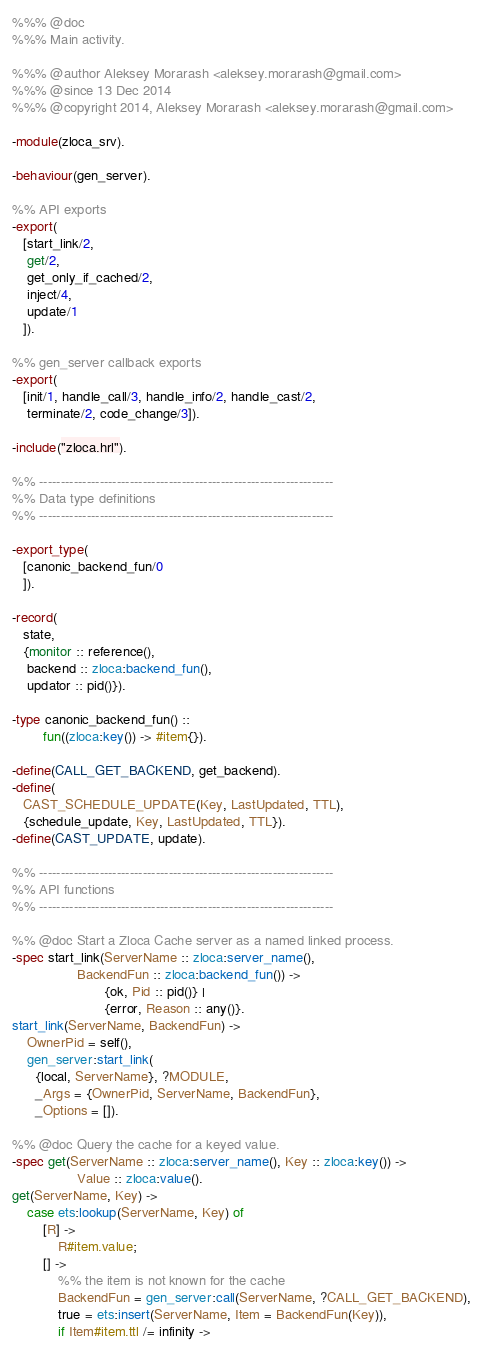Convert code to text. <code><loc_0><loc_0><loc_500><loc_500><_Erlang_>%%% @doc
%%% Main activity.

%%% @author Aleksey Morarash <aleksey.morarash@gmail.com>
%%% @since 13 Dec 2014
%%% @copyright 2014, Aleksey Morarash <aleksey.morarash@gmail.com>

-module(zloca_srv).

-behaviour(gen_server).

%% API exports
-export(
   [start_link/2,
    get/2,
    get_only_if_cached/2,
    inject/4,
    update/1
   ]).

%% gen_server callback exports
-export(
   [init/1, handle_call/3, handle_info/2, handle_cast/2,
    terminate/2, code_change/3]).

-include("zloca.hrl").

%% --------------------------------------------------------------------
%% Data type definitions
%% --------------------------------------------------------------------

-export_type(
   [canonic_backend_fun/0
   ]).

-record(
   state,
   {monitor :: reference(),
    backend :: zloca:backend_fun(),
    updator :: pid()}).

-type canonic_backend_fun() ::
        fun((zloca:key()) -> #item{}).

-define(CALL_GET_BACKEND, get_backend).
-define(
   CAST_SCHEDULE_UPDATE(Key, LastUpdated, TTL),
   {schedule_update, Key, LastUpdated, TTL}).
-define(CAST_UPDATE, update).

%% --------------------------------------------------------------------
%% API functions
%% --------------------------------------------------------------------

%% @doc Start a Zloca Cache server as a named linked process.
-spec start_link(ServerName :: zloca:server_name(),
                 BackendFun :: zloca:backend_fun()) ->
                        {ok, Pid :: pid()} |
                        {error, Reason :: any()}.
start_link(ServerName, BackendFun) ->
    OwnerPid = self(),
    gen_server:start_link(
      {local, ServerName}, ?MODULE,
      _Args = {OwnerPid, ServerName, BackendFun},
      _Options = []).

%% @doc Query the cache for a keyed value.
-spec get(ServerName :: zloca:server_name(), Key :: zloca:key()) ->
                 Value :: zloca:value().
get(ServerName, Key) ->
    case ets:lookup(ServerName, Key) of
        [R] ->
            R#item.value;
        [] ->
            %% the item is not known for the cache
            BackendFun = gen_server:call(ServerName, ?CALL_GET_BACKEND),
            true = ets:insert(ServerName, Item = BackendFun(Key)),
            if Item#item.ttl /= infinity -></code> 